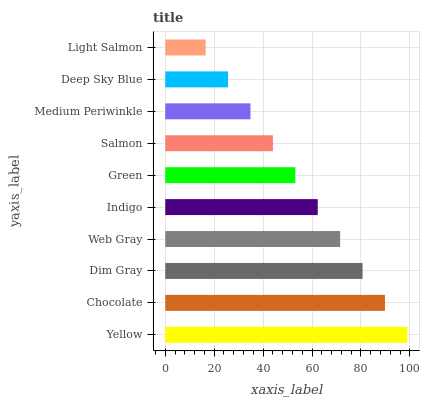Is Light Salmon the minimum?
Answer yes or no. Yes. Is Yellow the maximum?
Answer yes or no. Yes. Is Chocolate the minimum?
Answer yes or no. No. Is Chocolate the maximum?
Answer yes or no. No. Is Yellow greater than Chocolate?
Answer yes or no. Yes. Is Chocolate less than Yellow?
Answer yes or no. Yes. Is Chocolate greater than Yellow?
Answer yes or no. No. Is Yellow less than Chocolate?
Answer yes or no. No. Is Indigo the high median?
Answer yes or no. Yes. Is Green the low median?
Answer yes or no. Yes. Is Dim Gray the high median?
Answer yes or no. No. Is Dim Gray the low median?
Answer yes or no. No. 